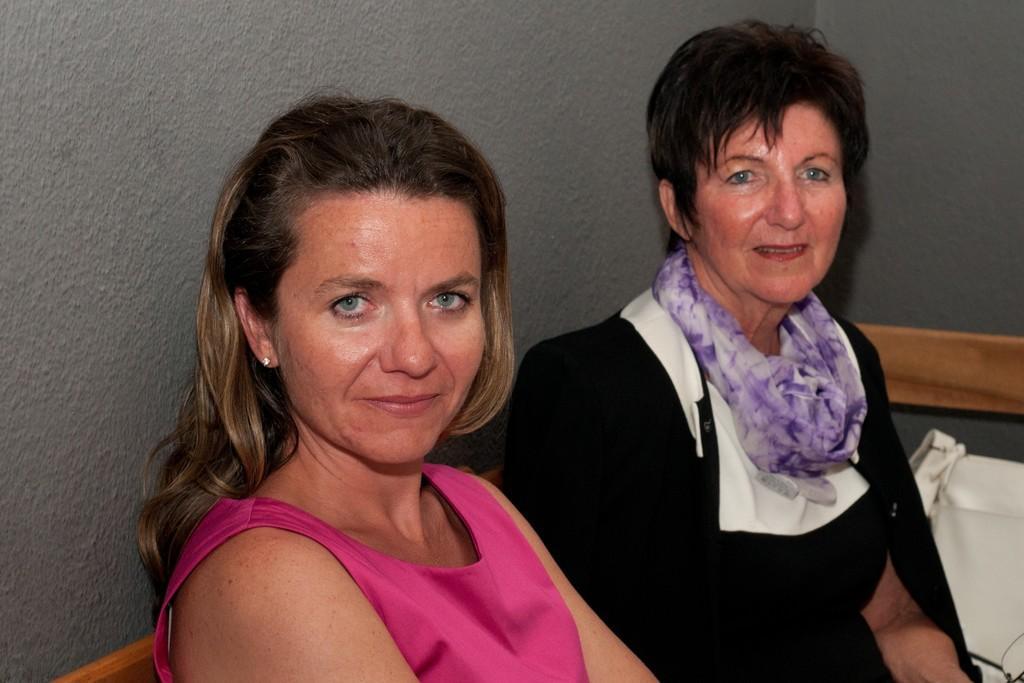In one or two sentences, can you explain what this image depicts? In this picture we can see two women sitting and smiling, white bag and in the background we can see the wall. 